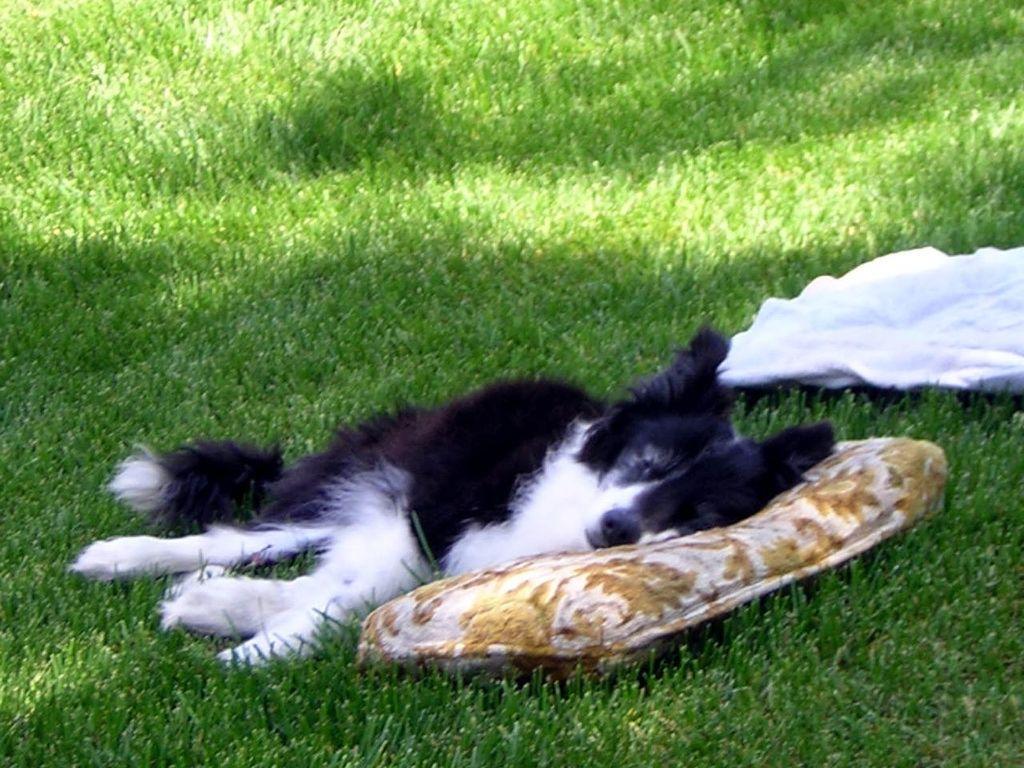Describe this image in one or two sentences. In this image we can see a dog lying on the grass. There is a cushion and a cloth placed on the grass. 